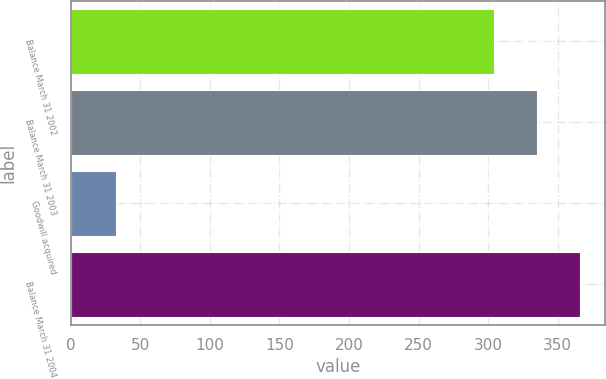Convert chart to OTSL. <chart><loc_0><loc_0><loc_500><loc_500><bar_chart><fcel>Balance March 31 2002<fcel>Balance March 31 2003<fcel>Goodwill acquired<fcel>Balance March 31 2004<nl><fcel>303.9<fcel>334.92<fcel>32.2<fcel>365.94<nl></chart> 